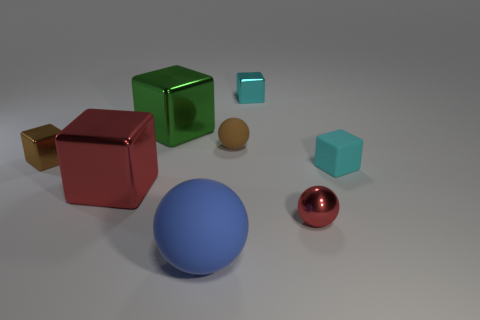What is the shape of the large blue matte thing?
Provide a succinct answer. Sphere. How many matte blocks are the same color as the tiny rubber sphere?
Offer a terse response. 0. What is the color of the shiny thing that is the same shape as the small brown rubber object?
Your response must be concise. Red. What number of objects are behind the large block that is in front of the small rubber sphere?
Your answer should be compact. 5. How many spheres are cyan matte objects or large green objects?
Keep it short and to the point. 0. Are there any large red shiny objects?
Your answer should be very brief. Yes. The blue rubber object that is the same shape as the small red object is what size?
Offer a very short reply. Large. What is the shape of the small metallic object that is to the left of the small sphere that is on the left side of the red ball?
Ensure brevity in your answer.  Cube. What number of blue things are large shiny objects or cylinders?
Give a very brief answer. 0. The large matte thing has what color?
Your answer should be compact. Blue. 